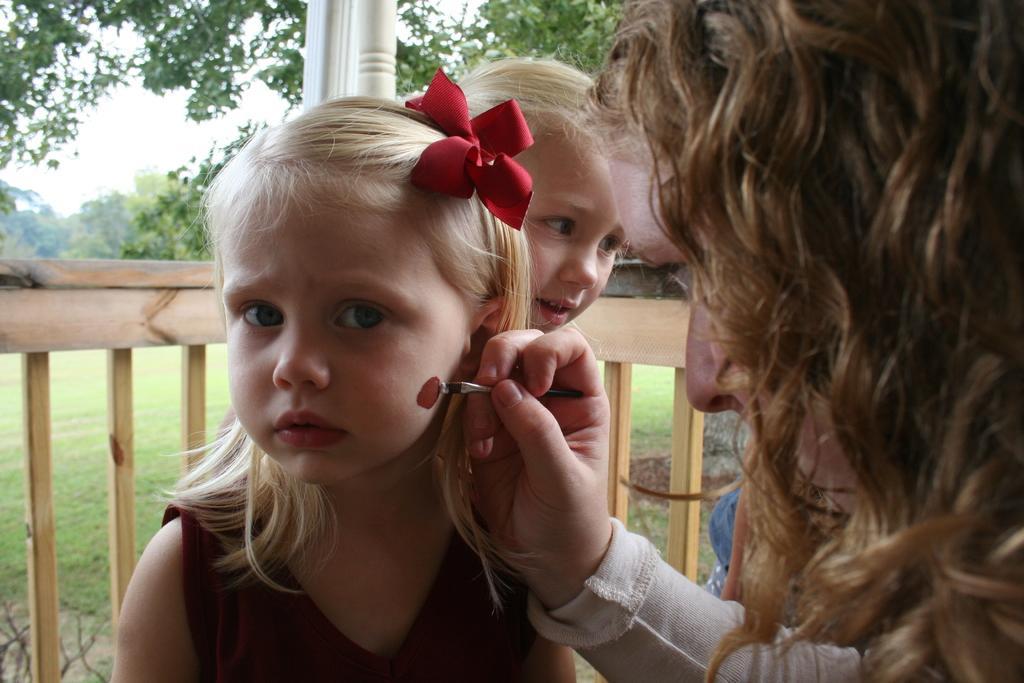In one or two sentences, can you explain what this image depicts? In this picture we can see two kids and a woman in the front, a woman is holding a brush, we can see wooden railing and grass in the middle, in the background there are trees and the sky. 